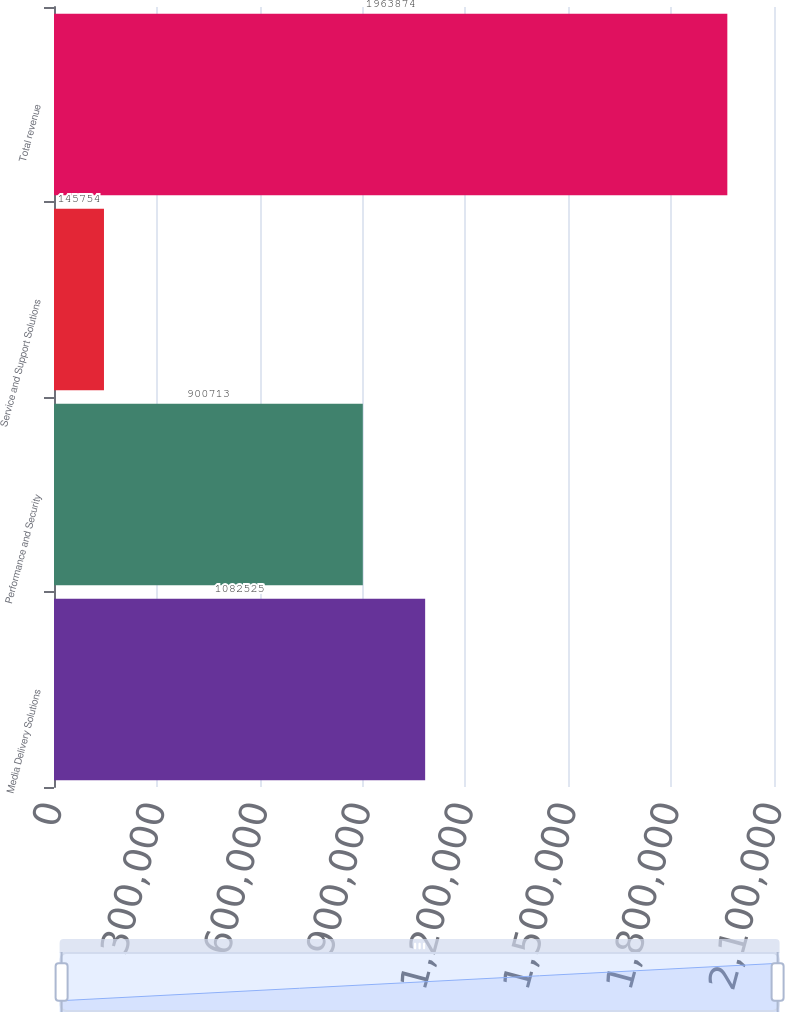Convert chart. <chart><loc_0><loc_0><loc_500><loc_500><bar_chart><fcel>Media Delivery Solutions<fcel>Performance and Security<fcel>Service and Support Solutions<fcel>Total revenue<nl><fcel>1.08252e+06<fcel>900713<fcel>145754<fcel>1.96387e+06<nl></chart> 